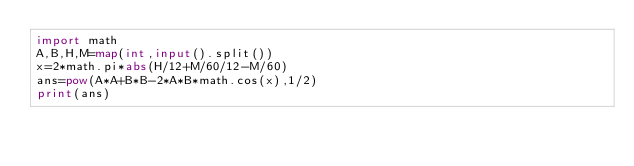Convert code to text. <code><loc_0><loc_0><loc_500><loc_500><_Python_>import math
A,B,H,M=map(int,input().split())
x=2*math.pi*abs(H/12+M/60/12-M/60)
ans=pow(A*A+B*B-2*A*B*math.cos(x),1/2)
print(ans)</code> 